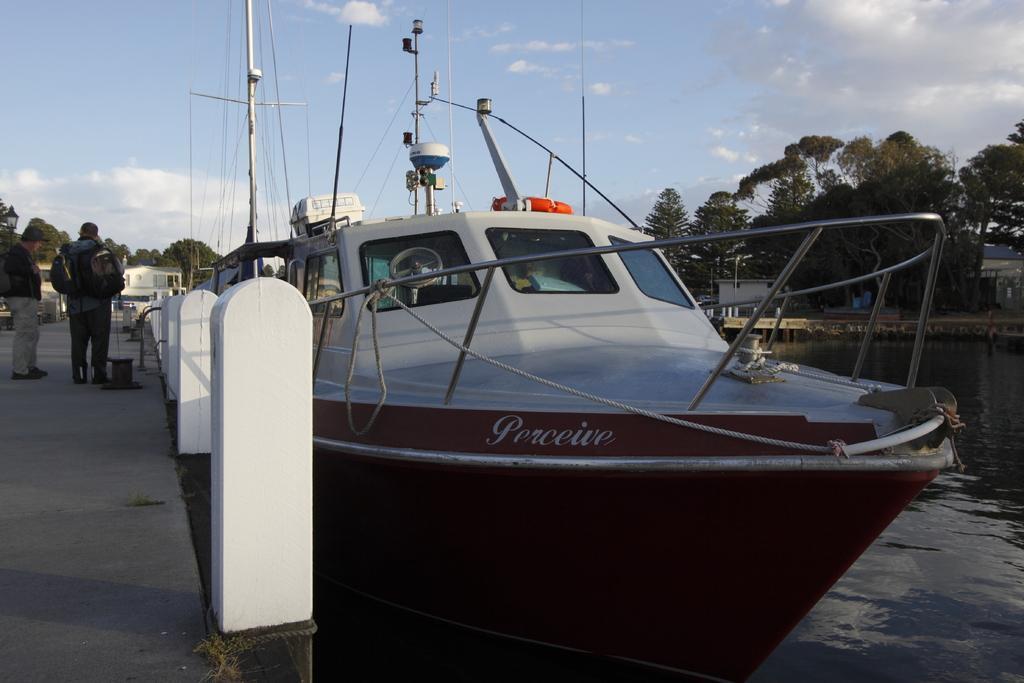Could you give a brief overview of what you see in this image? On the left side there is a pavement, on that there are people standing, beside the pavement there are pillars, on the right side there is a boat on a canal, in the background there are trees and the sky. 